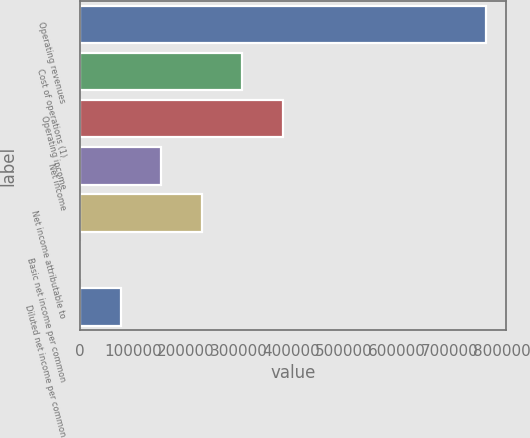<chart> <loc_0><loc_0><loc_500><loc_500><bar_chart><fcel>Operating revenues<fcel>Cost of operations (1)<fcel>Operating income<fcel>Net income<fcel>Net income attributable to<fcel>Basic net income per common<fcel>Diluted net income per common<nl><fcel>768374<fcel>307350<fcel>384187<fcel>153675<fcel>230512<fcel>0.34<fcel>76837.7<nl></chart> 